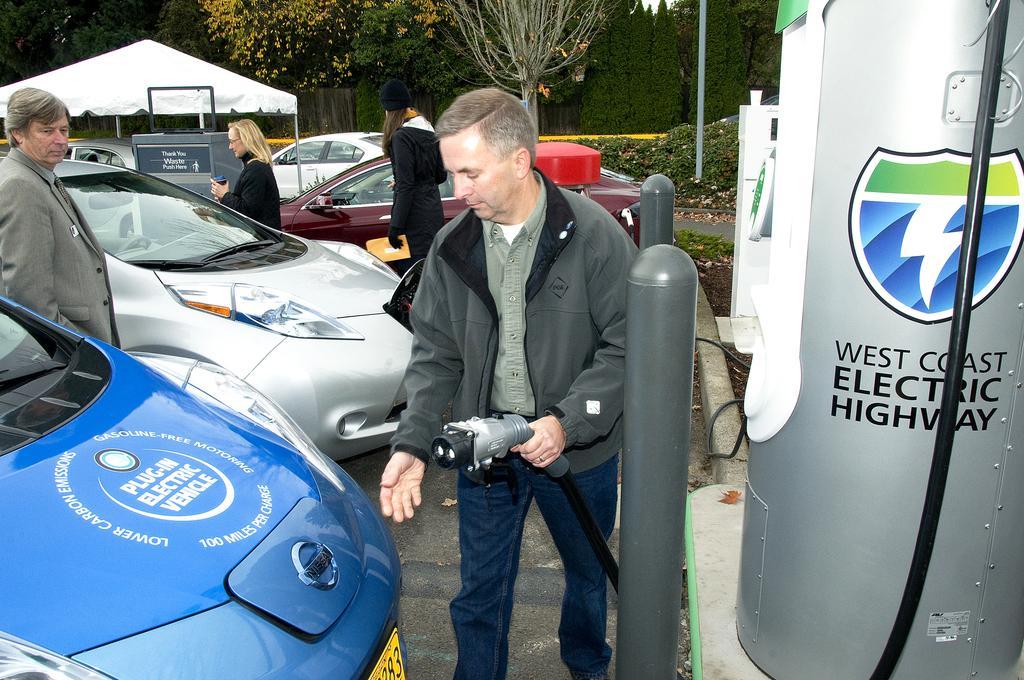How would you summarize this image in a sentence or two? In this picture we can see few people and cars, in the middle of the image we can find a man, he is holding a cable, beside him we can see few metal rods and a charging point, in the background we can see few trees and a tent. 